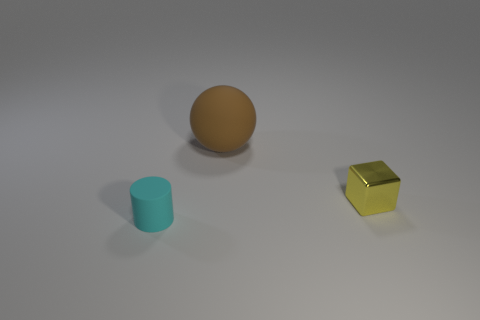Add 1 brown matte things. How many objects exist? 4 Subtract all cubes. How many objects are left? 2 Add 3 small shiny cubes. How many small shiny cubes are left? 4 Add 2 tiny cyan shiny things. How many tiny cyan shiny things exist? 2 Subtract 0 yellow spheres. How many objects are left? 3 Subtract all big gray metal cylinders. Subtract all small yellow metal blocks. How many objects are left? 2 